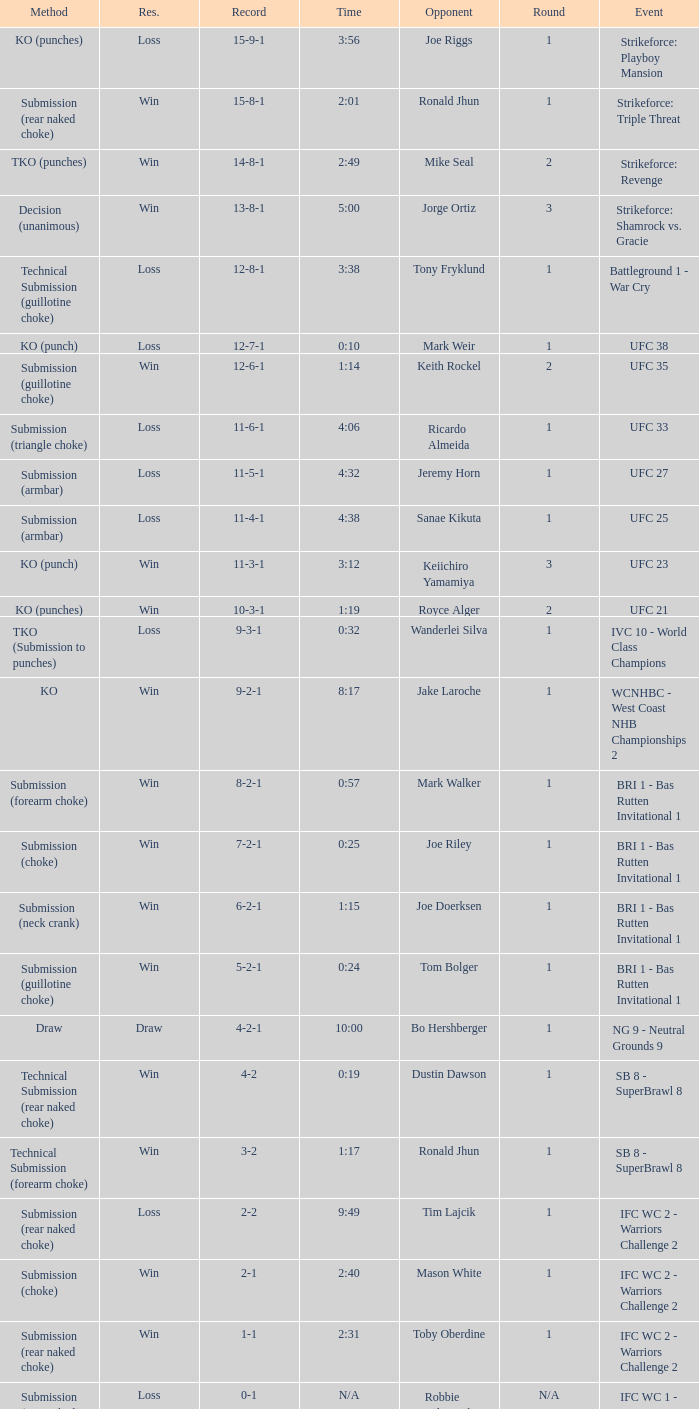Would you be able to parse every entry in this table? {'header': ['Method', 'Res.', 'Record', 'Time', 'Opponent', 'Round', 'Event'], 'rows': [['KO (punches)', 'Loss', '15-9-1', '3:56', 'Joe Riggs', '1', 'Strikeforce: Playboy Mansion'], ['Submission (rear naked choke)', 'Win', '15-8-1', '2:01', 'Ronald Jhun', '1', 'Strikeforce: Triple Threat'], ['TKO (punches)', 'Win', '14-8-1', '2:49', 'Mike Seal', '2', 'Strikeforce: Revenge'], ['Decision (unanimous)', 'Win', '13-8-1', '5:00', 'Jorge Ortiz', '3', 'Strikeforce: Shamrock vs. Gracie'], ['Technical Submission (guillotine choke)', 'Loss', '12-8-1', '3:38', 'Tony Fryklund', '1', 'Battleground 1 - War Cry'], ['KO (punch)', 'Loss', '12-7-1', '0:10', 'Mark Weir', '1', 'UFC 38'], ['Submission (guillotine choke)', 'Win', '12-6-1', '1:14', 'Keith Rockel', '2', 'UFC 35'], ['Submission (triangle choke)', 'Loss', '11-6-1', '4:06', 'Ricardo Almeida', '1', 'UFC 33'], ['Submission (armbar)', 'Loss', '11-5-1', '4:32', 'Jeremy Horn', '1', 'UFC 27'], ['Submission (armbar)', 'Loss', '11-4-1', '4:38', 'Sanae Kikuta', '1', 'UFC 25'], ['KO (punch)', 'Win', '11-3-1', '3:12', 'Keiichiro Yamamiya', '3', 'UFC 23'], ['KO (punches)', 'Win', '10-3-1', '1:19', 'Royce Alger', '2', 'UFC 21'], ['TKO (Submission to punches)', 'Loss', '9-3-1', '0:32', 'Wanderlei Silva', '1', 'IVC 10 - World Class Champions'], ['KO', 'Win', '9-2-1', '8:17', 'Jake Laroche', '1', 'WCNHBC - West Coast NHB Championships 2'], ['Submission (forearm choke)', 'Win', '8-2-1', '0:57', 'Mark Walker', '1', 'BRI 1 - Bas Rutten Invitational 1'], ['Submission (choke)', 'Win', '7-2-1', '0:25', 'Joe Riley', '1', 'BRI 1 - Bas Rutten Invitational 1'], ['Submission (neck crank)', 'Win', '6-2-1', '1:15', 'Joe Doerksen', '1', 'BRI 1 - Bas Rutten Invitational 1'], ['Submission (guillotine choke)', 'Win', '5-2-1', '0:24', 'Tom Bolger', '1', 'BRI 1 - Bas Rutten Invitational 1'], ['Draw', 'Draw', '4-2-1', '10:00', 'Bo Hershberger', '1', 'NG 9 - Neutral Grounds 9'], ['Technical Submission (rear naked choke)', 'Win', '4-2', '0:19', 'Dustin Dawson', '1', 'SB 8 - SuperBrawl 8'], ['Technical Submission (forearm choke)', 'Win', '3-2', '1:17', 'Ronald Jhun', '1', 'SB 8 - SuperBrawl 8'], ['Submission (rear naked choke)', 'Loss', '2-2', '9:49', 'Tim Lajcik', '1', 'IFC WC 2 - Warriors Challenge 2'], ['Submission (choke)', 'Win', '2-1', '2:40', 'Mason White', '1', 'IFC WC 2 - Warriors Challenge 2'], ['Submission (rear naked choke)', 'Win', '1-1', '2:31', 'Toby Oberdine', '1', 'IFC WC 2 - Warriors Challenge 2'], ['Submission (rear naked choke)', 'Loss', '0-1', 'N/A', 'Robbie Kilpatrick', 'N/A', 'IFC WC 1 - Warriors Challenge 1']]} What is the record during the event, UFC 27? 11-5-1. 